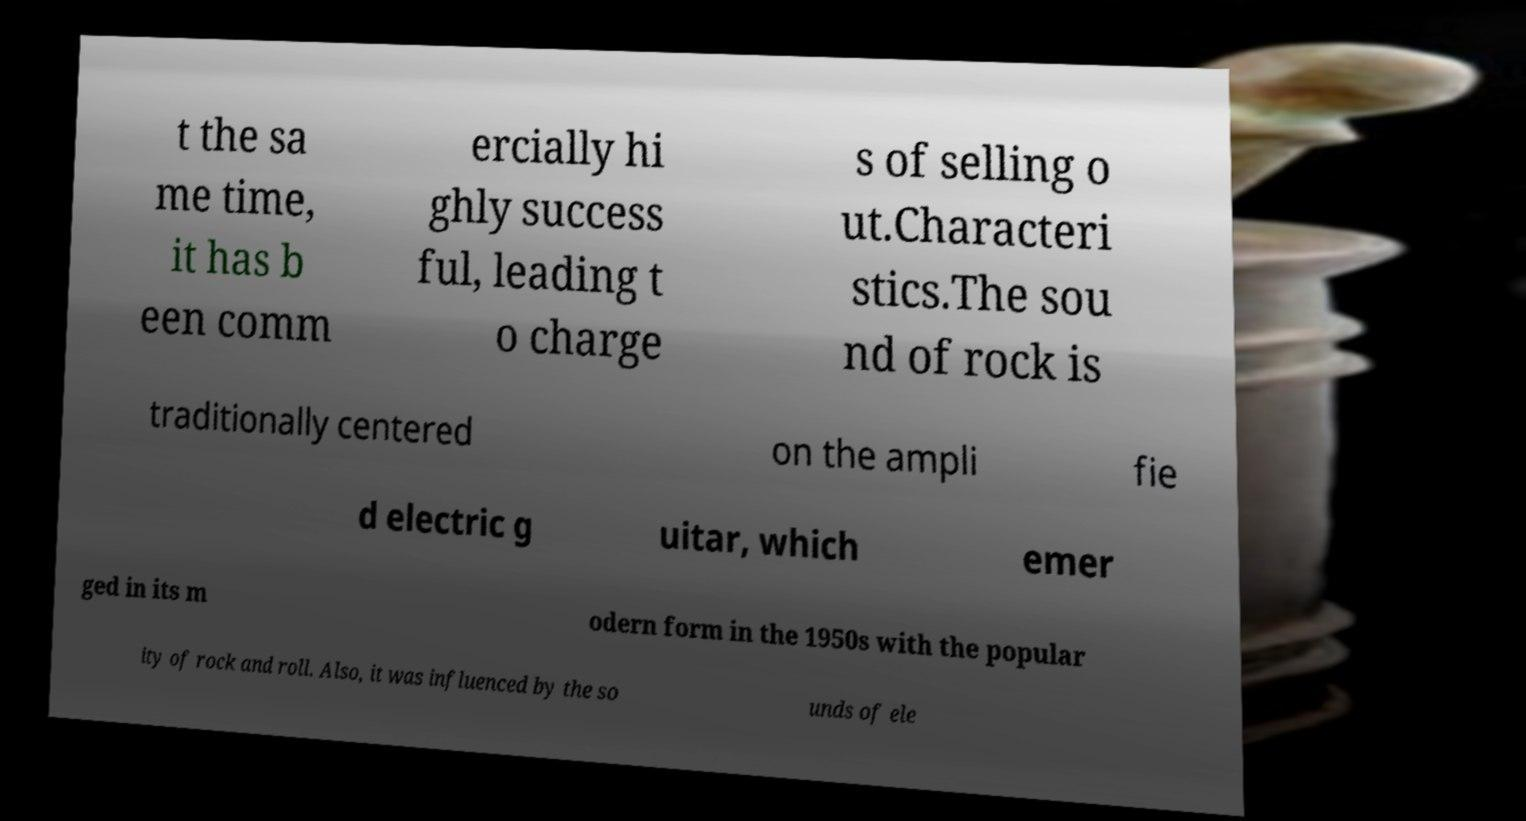I need the written content from this picture converted into text. Can you do that? t the sa me time, it has b een comm ercially hi ghly success ful, leading t o charge s of selling o ut.Characteri stics.The sou nd of rock is traditionally centered on the ampli fie d electric g uitar, which emer ged in its m odern form in the 1950s with the popular ity of rock and roll. Also, it was influenced by the so unds of ele 